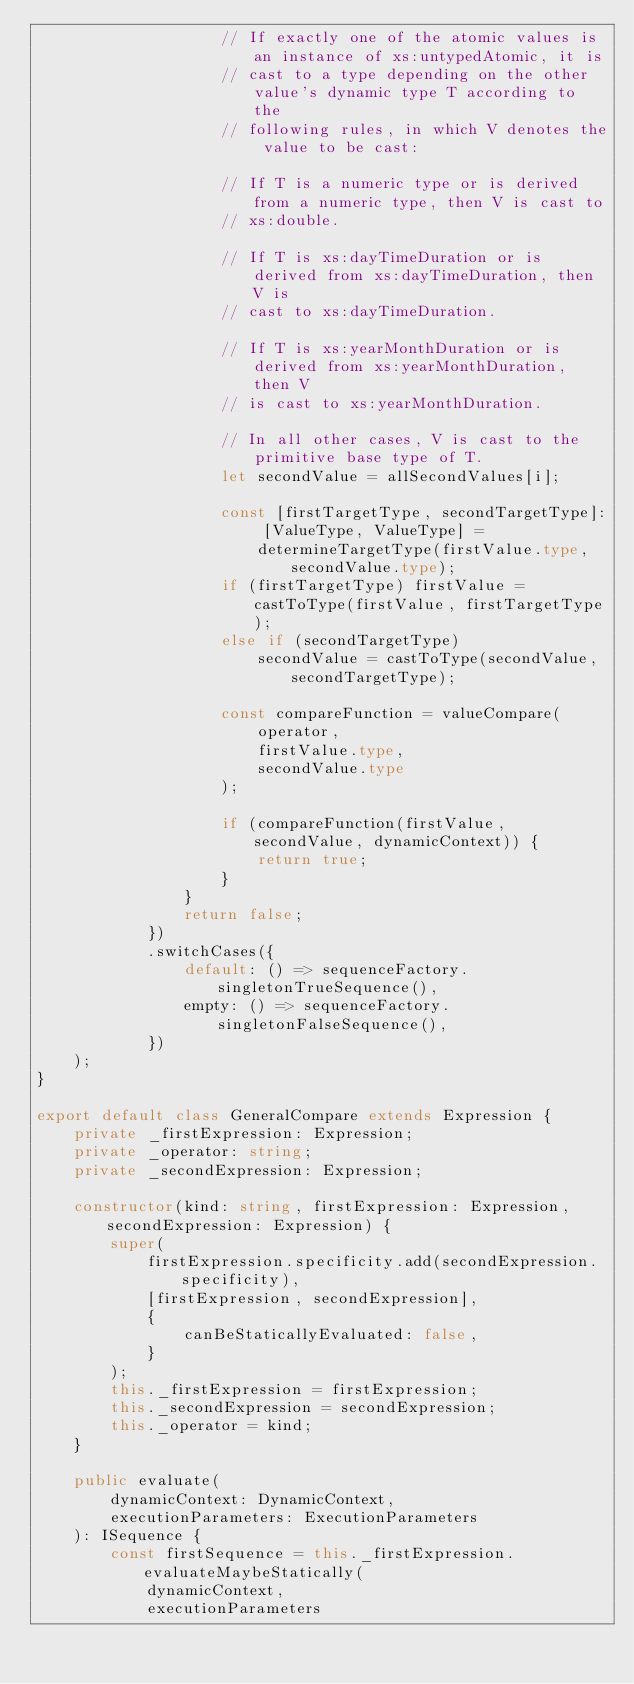Convert code to text. <code><loc_0><loc_0><loc_500><loc_500><_TypeScript_>					// If exactly one of the atomic values is an instance of xs:untypedAtomic, it is
					// cast to a type depending on the other value's dynamic type T according to the
					// following rules, in which V denotes the value to be cast:

					// If T is a numeric type or is derived from a numeric type, then V is cast to
					// xs:double.

					// If T is xs:dayTimeDuration or is derived from xs:dayTimeDuration, then V is
					// cast to xs:dayTimeDuration.

					// If T is xs:yearMonthDuration or is derived from xs:yearMonthDuration, then V
					// is cast to xs:yearMonthDuration.

					// In all other cases, V is cast to the primitive base type of T.
					let secondValue = allSecondValues[i];

					const [firstTargetType, secondTargetType]: [ValueType, ValueType] =
						determineTargetType(firstValue.type, secondValue.type);
					if (firstTargetType) firstValue = castToType(firstValue, firstTargetType);
					else if (secondTargetType)
						secondValue = castToType(secondValue, secondTargetType);

					const compareFunction = valueCompare(
						operator,
						firstValue.type,
						secondValue.type
					);

					if (compareFunction(firstValue, secondValue, dynamicContext)) {
						return true;
					}
				}
				return false;
			})
			.switchCases({
				default: () => sequenceFactory.singletonTrueSequence(),
				empty: () => sequenceFactory.singletonFalseSequence(),
			})
	);
}

export default class GeneralCompare extends Expression {
	private _firstExpression: Expression;
	private _operator: string;
	private _secondExpression: Expression;

	constructor(kind: string, firstExpression: Expression, secondExpression: Expression) {
		super(
			firstExpression.specificity.add(secondExpression.specificity),
			[firstExpression, secondExpression],
			{
				canBeStaticallyEvaluated: false,
			}
		);
		this._firstExpression = firstExpression;
		this._secondExpression = secondExpression;
		this._operator = kind;
	}

	public evaluate(
		dynamicContext: DynamicContext,
		executionParameters: ExecutionParameters
	): ISequence {
		const firstSequence = this._firstExpression.evaluateMaybeStatically(
			dynamicContext,
			executionParameters</code> 